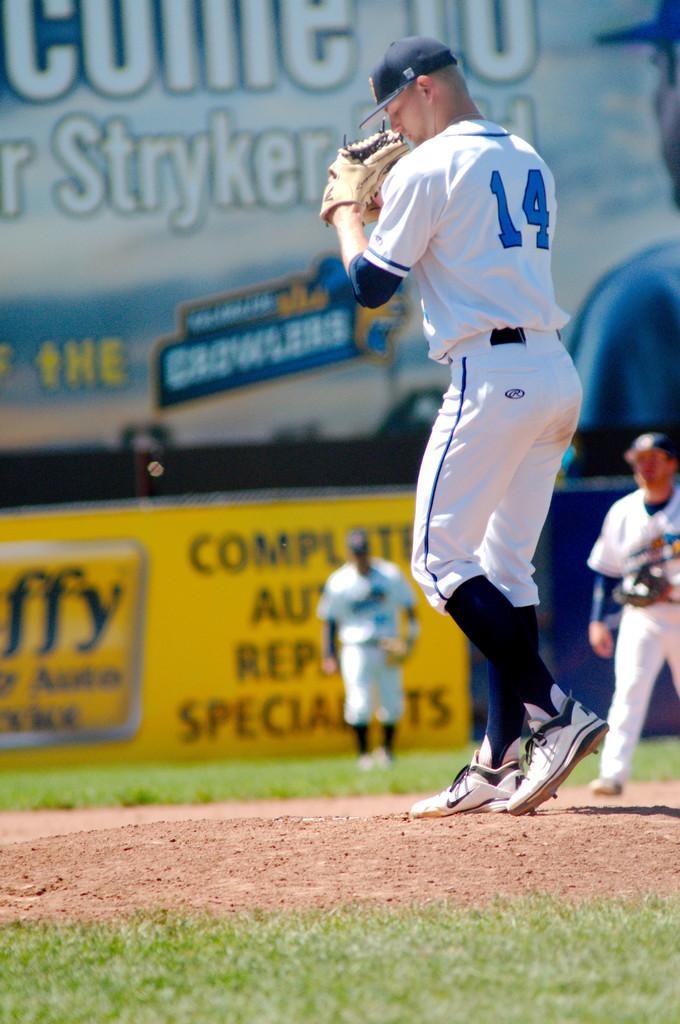Provide a one-sentence caption for the provided image. The player has a jersey that has the number 14 on it. 